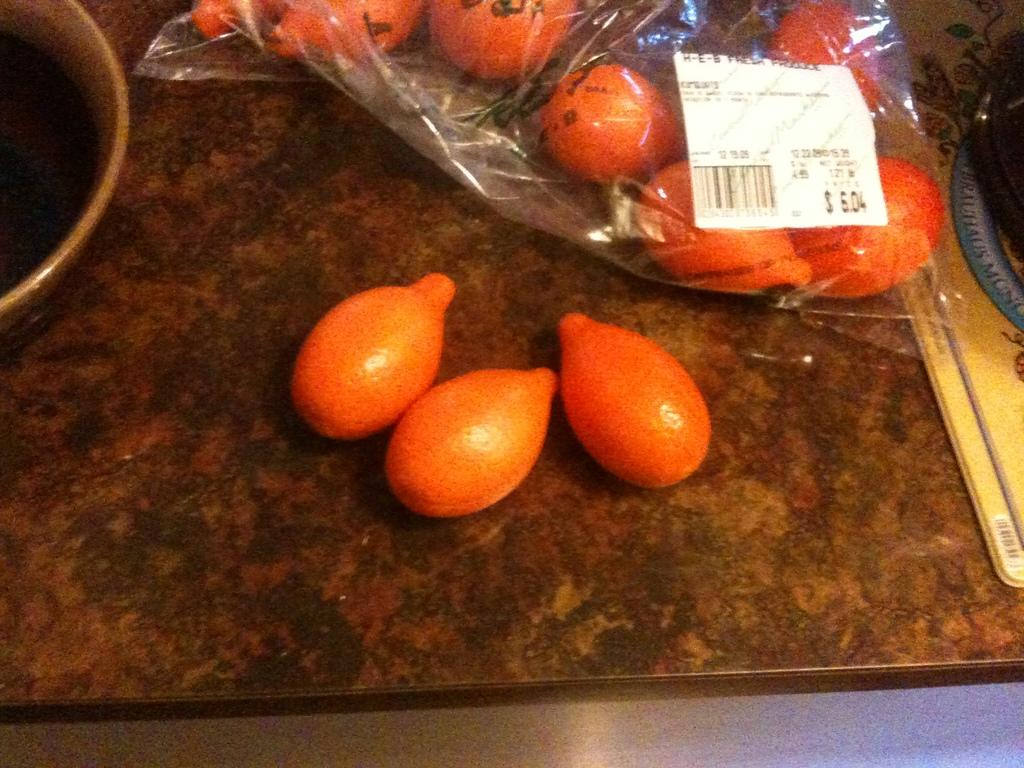What is placed on the stone in the image? There are fruits on a stone in the image. What else can be seen in the image besides the fruits on the stone? There are containers in the image. How many frogs are sitting on the fruits in the image? There are no frogs present in the image. What message of peace can be seen in the image? There is no message of peace depicted in the image. 